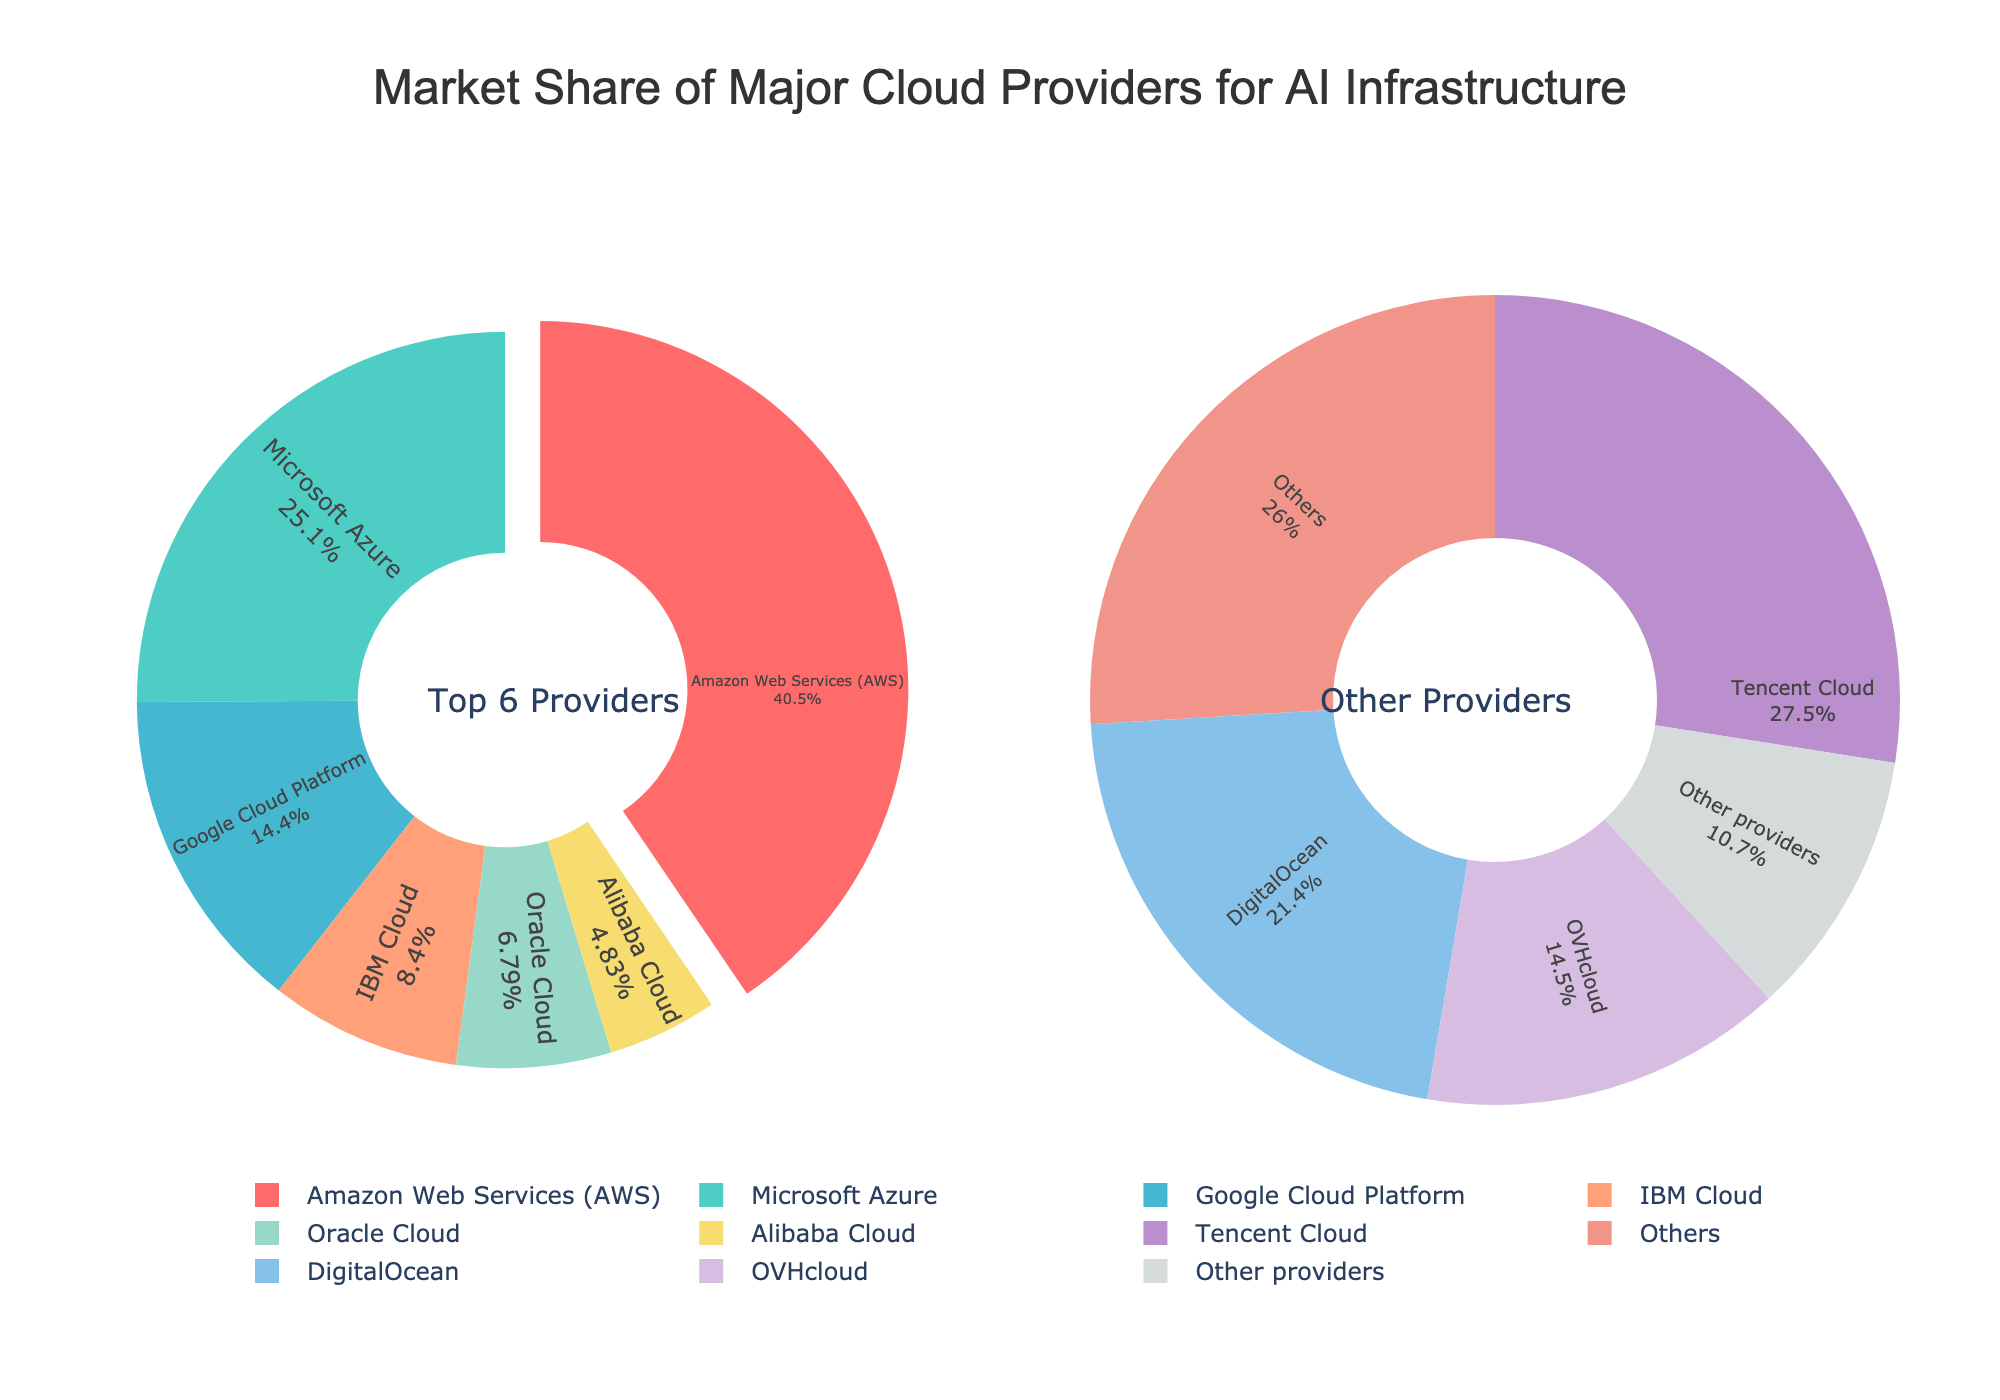What is the combined market share of Microsoft Azure and Google Cloud Platform? To find the combined market share, add the market shares of Microsoft Azure (21.8%) and Google Cloud Platform (12.5%): 21.8 + 12.5 = 34.3%
Answer: 34.3% Which cloud provider has the largest market share? The largest wedge in the "Top 6 Providers" pie chart denotes the cloud provider with the largest market share, which is Amazon Web Services (AWS) at 35.2%.
Answer: Amazon Web Services (AWS) Which providers together make up more than half of the total market share in the "Top 6 Providers" pie chart? Add the market shares of providers in the "Top 6 Providers" pie chart until the sum exceeds 50%: AWS (35.2%) + Microsoft Azure (21.8%) = 57%. Since 57% is already above 50%, AWS and Microsoft Azure together make up more than half of the total market share.
Answer: AWS and Microsoft Azure How much more market share does AWS have compared to Oracle Cloud? Subtract Oracle Cloud's market share (5.9%) from AWS's market share (35.2%): 35.2 - 5.9 = 29.3%
Answer: 29.3% What is the approximate percentage of the market share represented by "Other providers" in the secondary pie chart? The "Other providers" slice is detailed in the secondary pie chart, summing smaller individual market shares and the "Others" category (3.4%): Combining all smaller shares and "Others" roughly sums to around 100% for the secondary chart, but each specific category, including "Other providers," is part of the primary pie's drop-off.
Answer: (Approximation needed based on the main pie) Which provider is represented by the light blue color in the "Top 6 Providers" pie chart? In the "Top 6 Providers" pie chart, the light blue slice corresponds to the Google Cloud Platform. Visual identification indicates the placement and distinct color used for representation.
Answer: Google Cloud Platform How does the market share of DigitalOcean compare to that of Linode? By comparing slice sizes or percentages listed in the secondary pie chart, DigitalOcean has a higher market share than Linode (2.8% vs. 1.4%).
Answer: DigitalOcean > Linode What percentage of the market is accounted for by the top three cloud providers together? Add the market shares of AWS (35.2%), Microsoft Azure (21.8%), and Google Cloud Platform (12.5%): 35.2 + 21.8 + 12.5 = 69.5%.
Answer: 69.5% What are the total market shares of the providers listed in the secondary pie chart? Sum the market shares in the secondary pie chart: Alibaba Cloud (4.2%), Tencent Cloud (3.6%), DigitalOcean (2.8%), OVHcloud (1.9%), Linode (1.4%), and Others (3.4%): 4.2 + 3.6 + 2.8 + 1.9 + 1.4 + 3.4 = 17.3%.
Answer: 17.3% By how many percentage points does the market share of Microsoft Azure exceed that of IBM Cloud? Subtract IBM Cloud's market share (7.3%) from Microsoft Azure's market share (21.8%): 21.8 - 7.3 = 14.5%.
Answer: 14.5% 